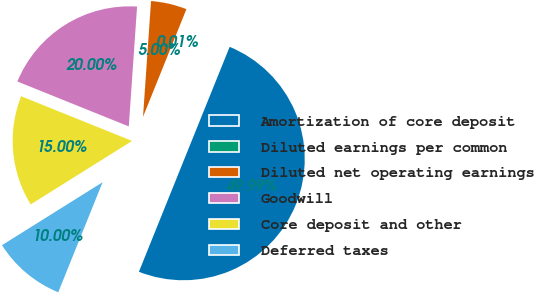Convert chart. <chart><loc_0><loc_0><loc_500><loc_500><pie_chart><fcel>Amortization of core deposit<fcel>Diluted earnings per common<fcel>Diluted net operating earnings<fcel>Goodwill<fcel>Core deposit and other<fcel>Deferred taxes<nl><fcel>49.99%<fcel>0.01%<fcel>5.0%<fcel>20.0%<fcel>15.0%<fcel>10.0%<nl></chart> 